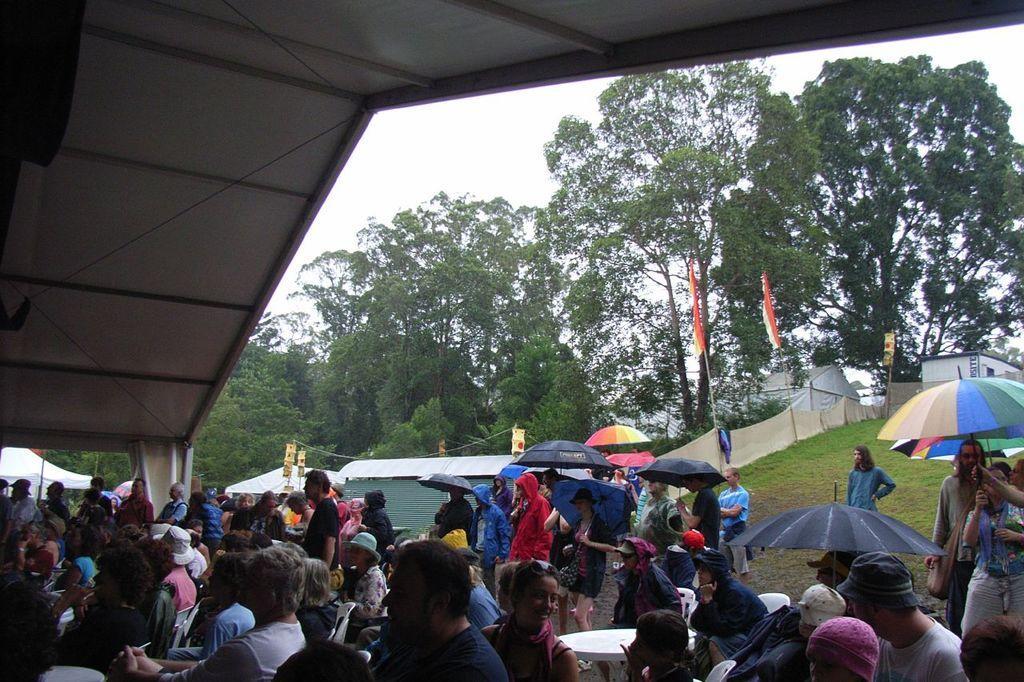Please provide a concise description of this image. In this picture we can see a group of people and few people are holding umbrellas, here we can see tents, flags, chairs and in the background we can see trees and the sky. 